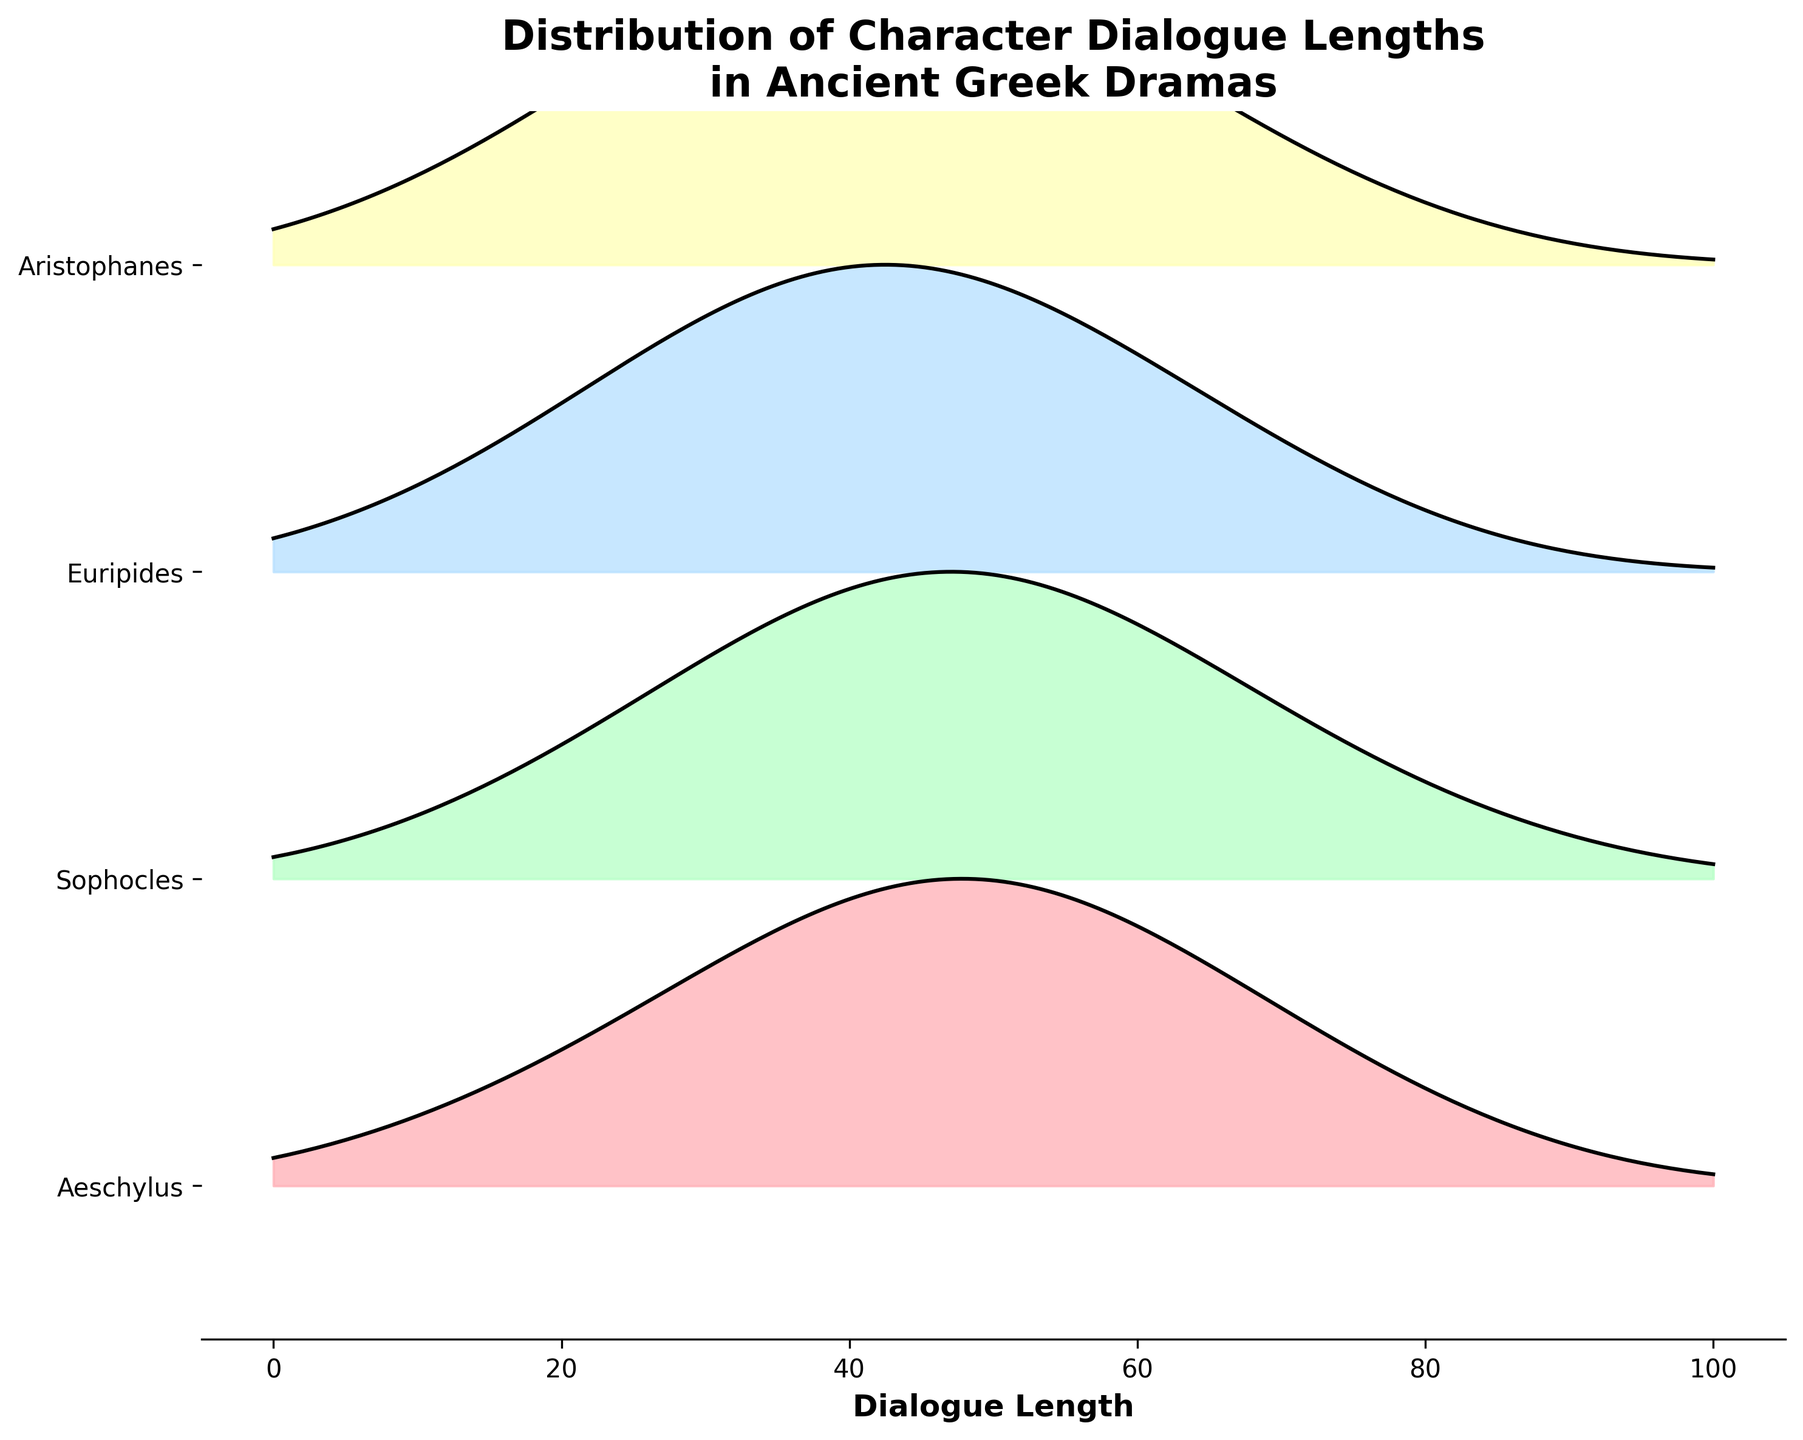What is the title of the figure? The title of the figure can be found at the top center of the plot and it summarizes the main idea of the plot.
Answer: Distribution of Character Dialogue Lengths in Ancient Greek Dramas Which playwrights are included in the figure? By looking at the labels on the y-axis, we can identify each playwright represented in the plot.
Answer: Aeschylus, Sophocles, Euripides, Aristophanes Between which dialogue lengths is Aeschylus's density highest? To find the dialogue length with the highest density for Aeschylus, we need to observe where the peak of Aeschylus's ridgeline is.
Answer: Between 40 and 50 Which playwright has the longest range of dialogue lengths? We need to compare the range (minimum to maximum dialogue lengths) for each playwright represented in the plot.
Answer: Euripides Do all playwrights show a unimodal distribution? By observing the density shapes for each playwright, we can determine if they have a single peak indicating a unimodal distribution.
Answer: Yes Which playwright has the steepest peak in dialogue length density? The steepness of the peak is determined by how sharp and high the density rise is for each playwright.
Answer: Euripides Which playwrights have some dialogue densities above 0.1? By inspecting the density values on the plot, we can determine which playwrights' curves go above the 0.1 density mark.
Answer: Aeschylus, Sophocles, Euripides, Aristophanes Compare the dialogue lengths with the highest density for Sophocles and Aristophanes. Identify the peak dialogue length for each playwright by looking at the curves, then compare these values.
Answer: 45 for Sophocles, 38 for Aristophanes What is the highest density value for Euripides's dialogues? Determine the peak density value by looking at Euripides’s ridgeline and identifying the maximum density point.
Answer: 0.16 Does Aeschylus have any dialogue lengths with a density as low as 0.02? Check the density values along Aeschylus’s ridgeline to see if any points drop to 0.02.
Answer: Yes 